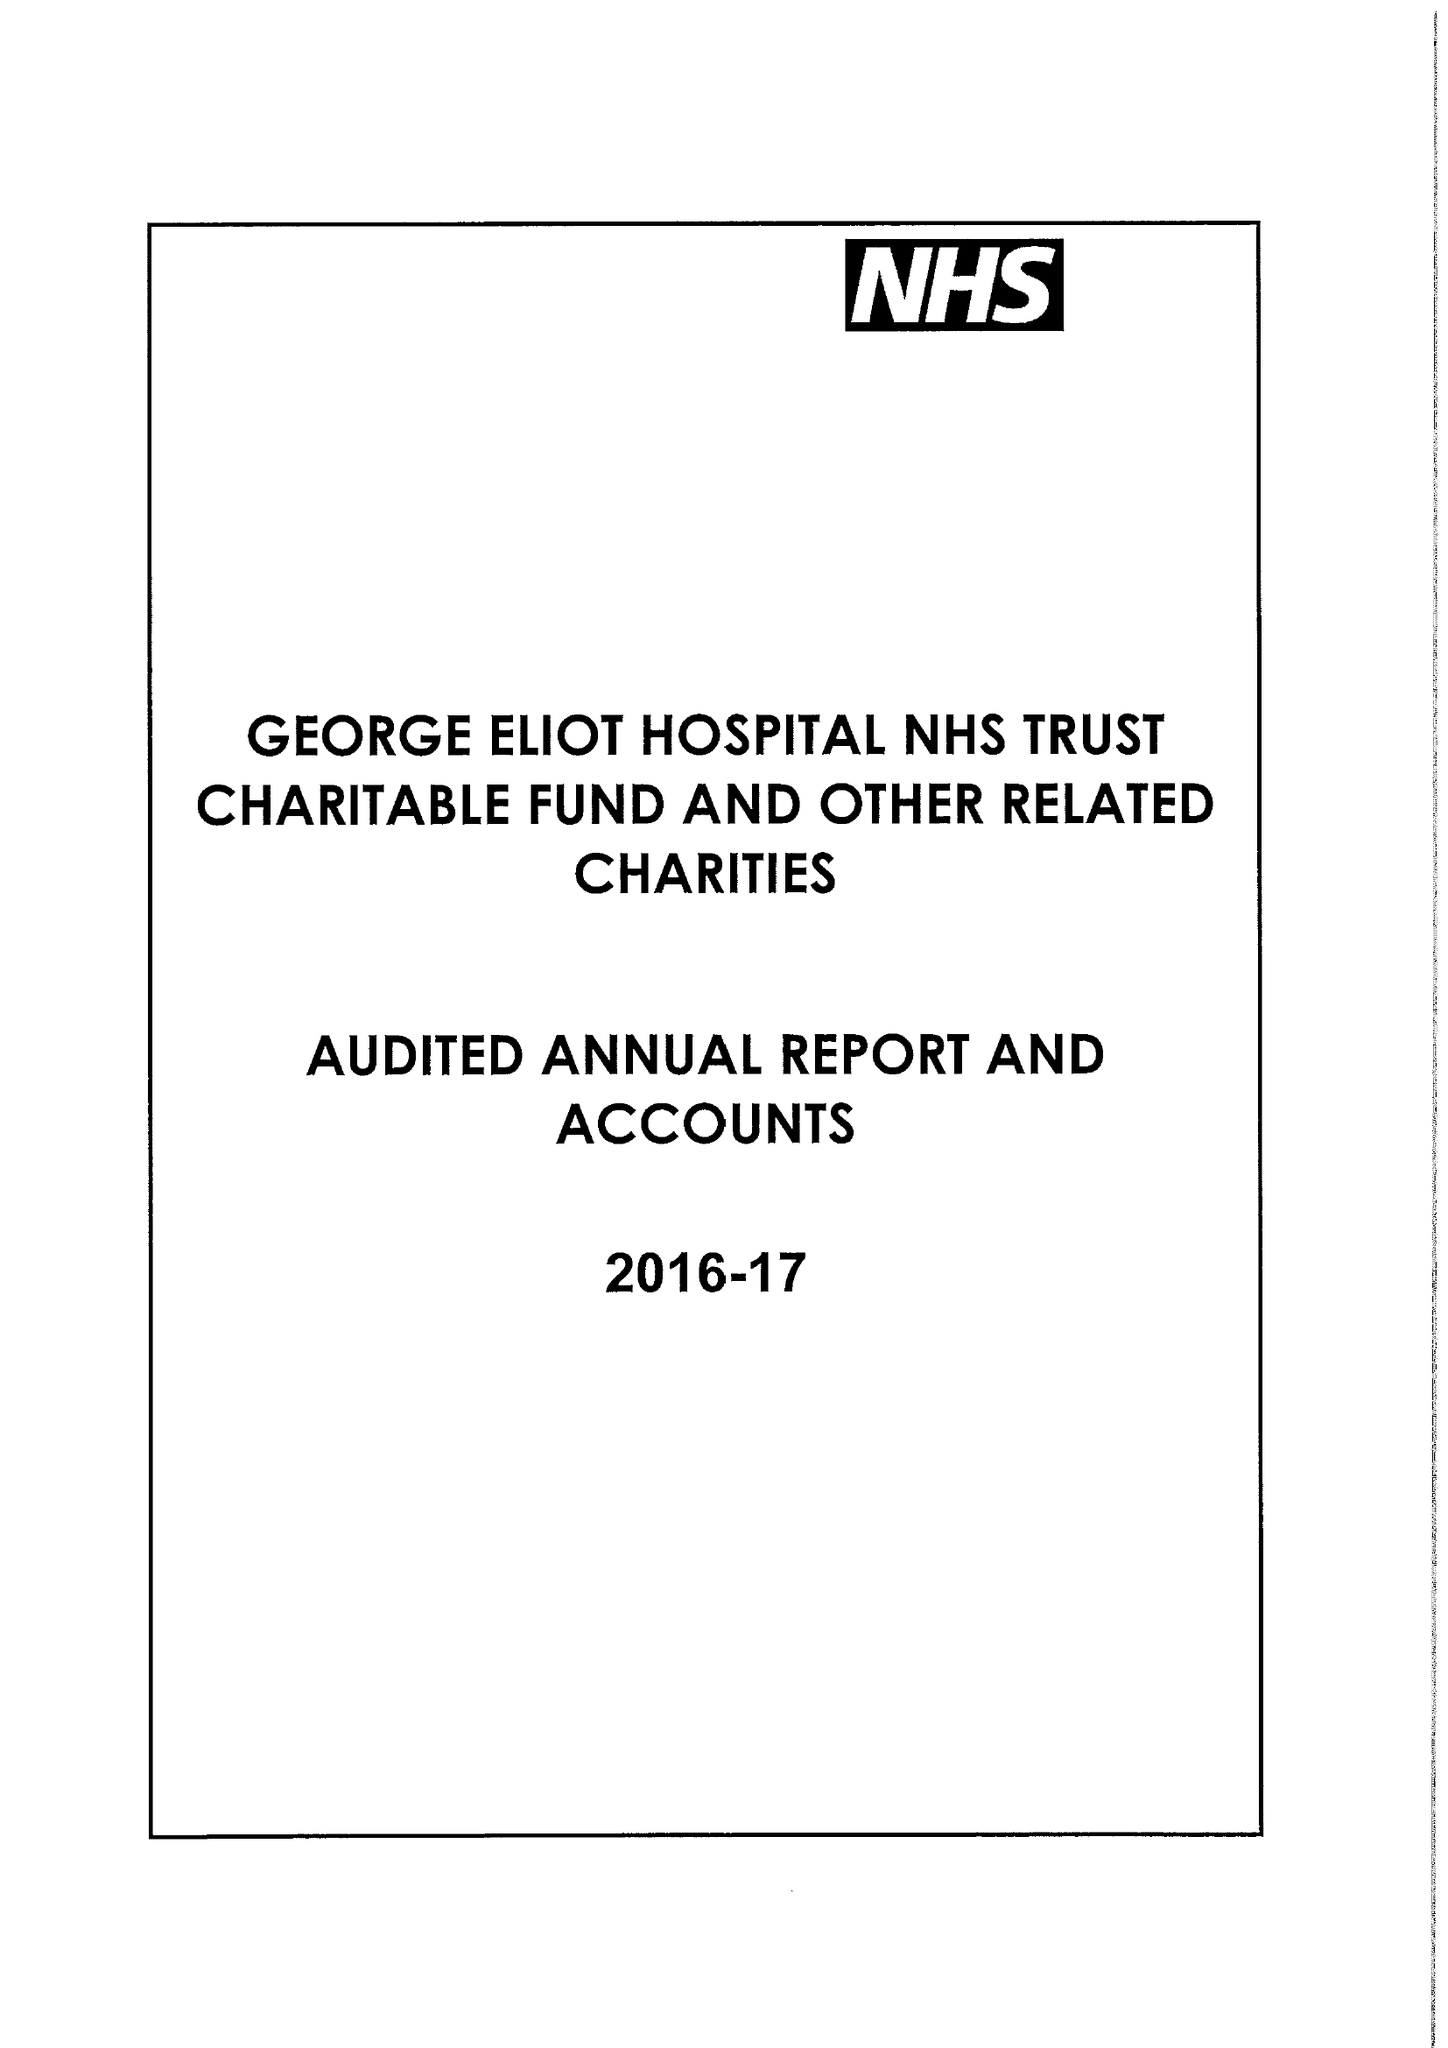What is the value for the address__post_town?
Answer the question using a single word or phrase. NUNEATON 